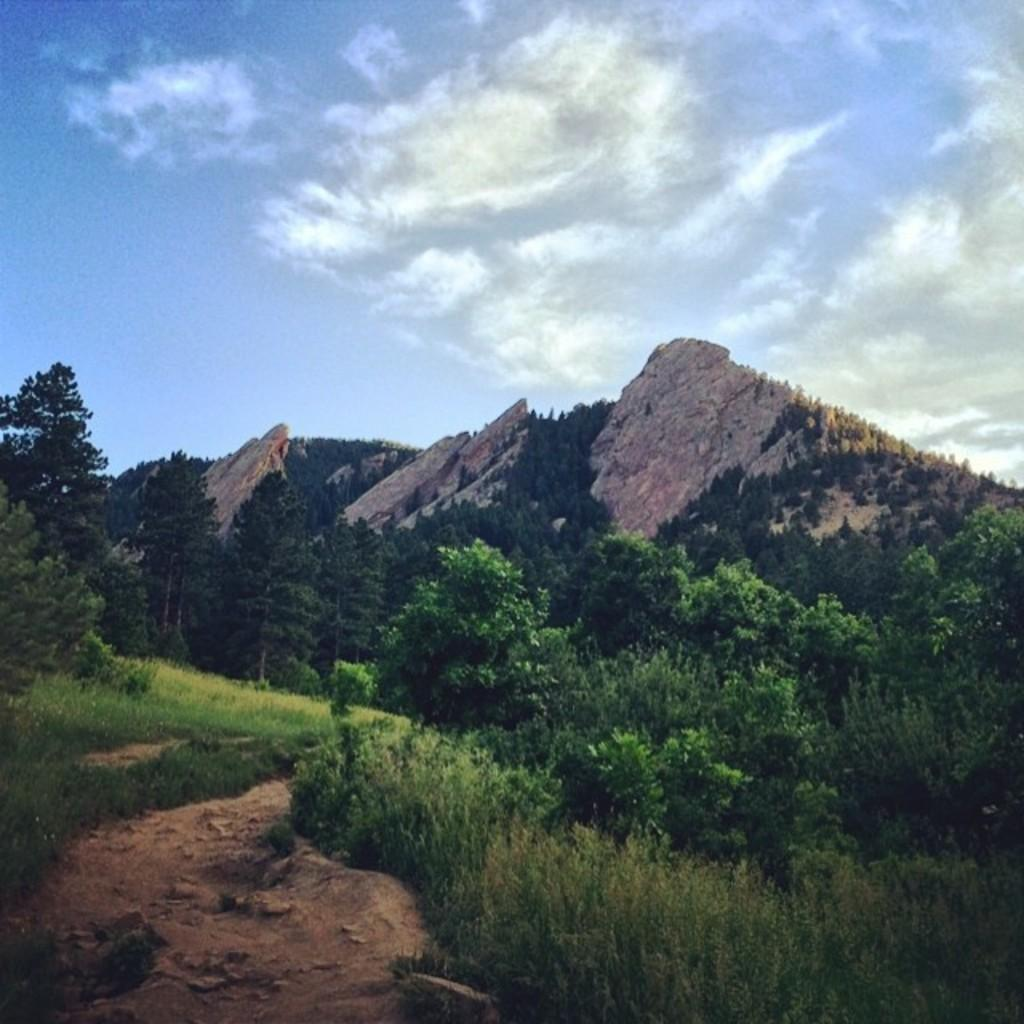What type of vegetation can be seen in the image? There is a group of trees, plants, and grass visible in the image. What kind of surface can be used for walking or running in the image? There is a pathway in the image that can be used for walking or running. What is visible in the background of the image? Mountains and the sky are visible in the background of the image. What is the condition of the sky in the image? The sky appears to be cloudy in the image. Can you tell me how many tramps are sitting on the ground in the image? There are no tramps or any ground visible in the image; it features a group of trees, plants, grass, a pathway, mountains, and a cloudy sky. 